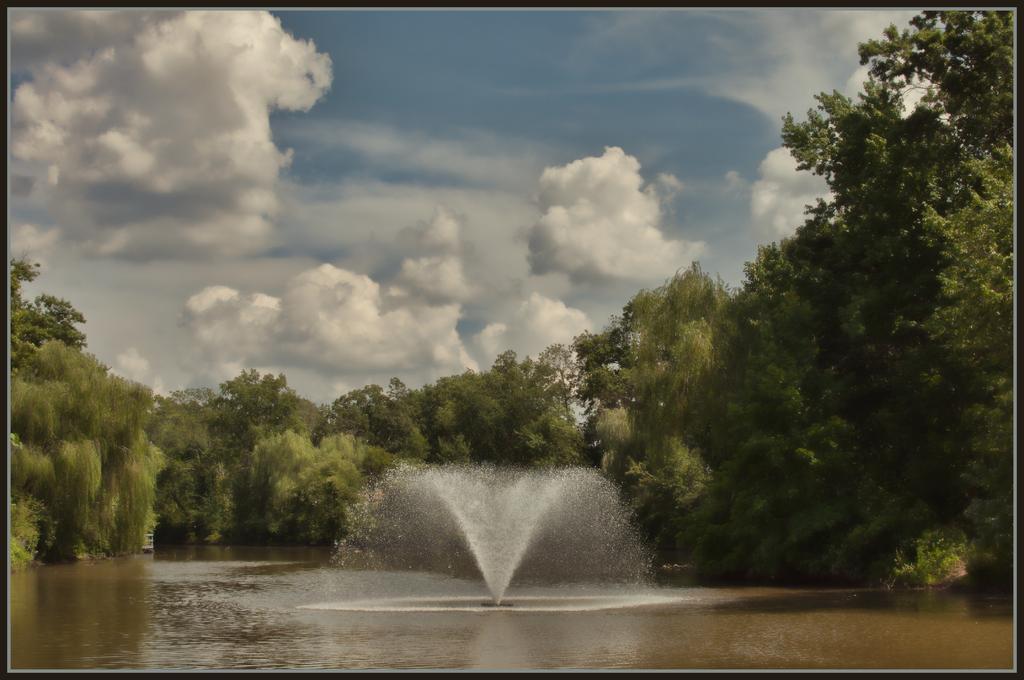Describe this image in one or two sentences. In this picture there is water and there is a fountain in between it and there are trees in the background and the sky is a bit cloudy. 